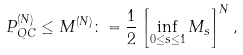<formula> <loc_0><loc_0><loc_500><loc_500>P _ { Q C } ^ { ( N ) } \leq M ^ { ( N ) } \colon = \frac { 1 } { 2 } \left [ \inf _ { 0 \leq s \leq 1 } M _ { s } \right ] ^ { N } ,</formula> 